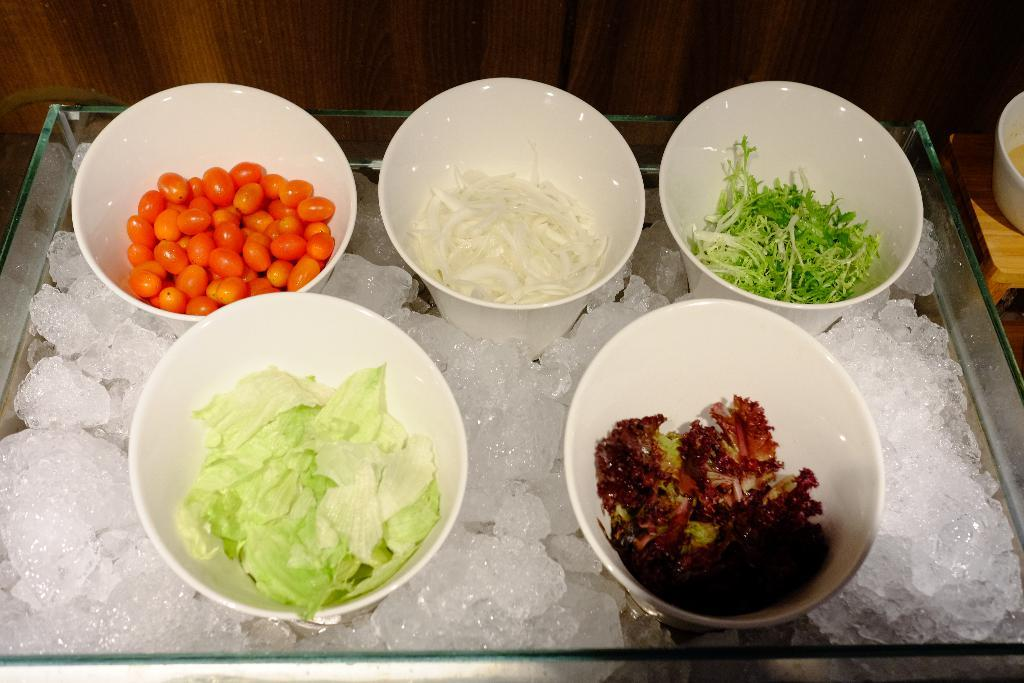What type of objects are present in the image? There are food items in the image. How are the food items presented? The food items are in white color bowls. What is the base material for the bowls? The bowls are on ice pieces. Where are the ice pieces located? The ice pieces are in a glass tray. What type of ring can be seen on the finger of the person holding the instrument in the image? There is no person holding an instrument or wearing a ring in the image. 